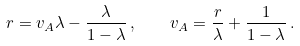<formula> <loc_0><loc_0><loc_500><loc_500>r = v _ { A } \lambda - \frac { \lambda } { 1 - \lambda } \, , \quad v _ { A } = \frac { r } { \lambda } + \frac { 1 } { 1 - \lambda } \, .</formula> 